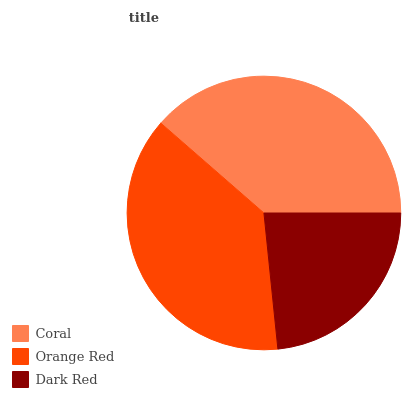Is Dark Red the minimum?
Answer yes or no. Yes. Is Coral the maximum?
Answer yes or no. Yes. Is Orange Red the minimum?
Answer yes or no. No. Is Orange Red the maximum?
Answer yes or no. No. Is Coral greater than Orange Red?
Answer yes or no. Yes. Is Orange Red less than Coral?
Answer yes or no. Yes. Is Orange Red greater than Coral?
Answer yes or no. No. Is Coral less than Orange Red?
Answer yes or no. No. Is Orange Red the high median?
Answer yes or no. Yes. Is Orange Red the low median?
Answer yes or no. Yes. Is Dark Red the high median?
Answer yes or no. No. Is Coral the low median?
Answer yes or no. No. 